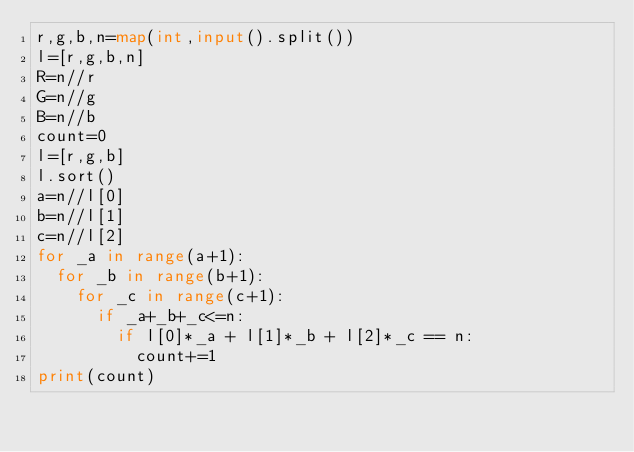<code> <loc_0><loc_0><loc_500><loc_500><_Python_>r,g,b,n=map(int,input().split())
l=[r,g,b,n]
R=n//r
G=n//g
B=n//b
count=0
l=[r,g,b]
l.sort()
a=n//l[0]
b=n//l[1]
c=n//l[2]
for _a in range(a+1):
  for _b in range(b+1):
    for _c in range(c+1):
      if _a+_b+_c<=n:
        if l[0]*_a + l[1]*_b + l[2]*_c == n:
          count+=1
print(count)</code> 